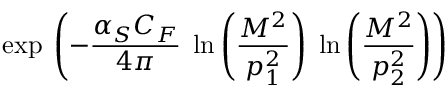<formula> <loc_0><loc_0><loc_500><loc_500>\exp \, \left ( - \frac { \alpha _ { S } C _ { F } } { 4 \pi } \, \ln \left ( \frac { M ^ { 2 } } { p _ { 1 } ^ { 2 } } \right ) \, \ln \left ( \frac { M ^ { 2 } } { p _ { 2 } ^ { 2 } } \right ) \right )</formula> 